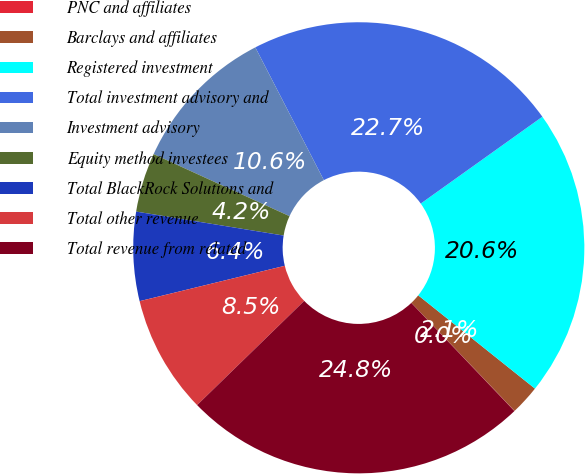Convert chart to OTSL. <chart><loc_0><loc_0><loc_500><loc_500><pie_chart><fcel>PNC and affiliates<fcel>Barclays and affiliates<fcel>Registered investment<fcel>Total investment advisory and<fcel>Investment advisory<fcel>Equity method investees<fcel>Total BlackRock Solutions and<fcel>Total other revenue<fcel>Total revenue from related<nl><fcel>0.02%<fcel>2.13%<fcel>20.6%<fcel>22.72%<fcel>10.6%<fcel>4.25%<fcel>6.37%<fcel>8.48%<fcel>24.84%<nl></chart> 